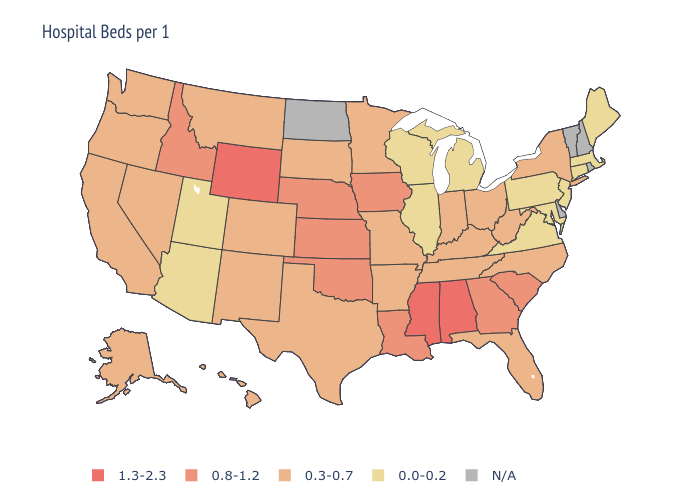Which states hav the highest value in the South?
Give a very brief answer. Alabama, Mississippi. Name the states that have a value in the range 0.8-1.2?
Short answer required. Georgia, Idaho, Iowa, Kansas, Louisiana, Nebraska, Oklahoma, South Carolina. What is the value of Arizona?
Write a very short answer. 0.0-0.2. What is the highest value in states that border North Carolina?
Keep it brief. 0.8-1.2. What is the highest value in the South ?
Keep it brief. 1.3-2.3. Name the states that have a value in the range 0.8-1.2?
Short answer required. Georgia, Idaho, Iowa, Kansas, Louisiana, Nebraska, Oklahoma, South Carolina. What is the value of South Dakota?
Give a very brief answer. 0.3-0.7. What is the value of Delaware?
Short answer required. N/A. Among the states that border Kentucky , which have the highest value?
Answer briefly. Indiana, Missouri, Ohio, Tennessee, West Virginia. Does New York have the lowest value in the Northeast?
Concise answer only. No. Does the first symbol in the legend represent the smallest category?
Keep it brief. No. Does the first symbol in the legend represent the smallest category?
Concise answer only. No. What is the lowest value in states that border Colorado?
Be succinct. 0.0-0.2. Among the states that border Wyoming , does Colorado have the lowest value?
Short answer required. No. What is the highest value in the South ?
Keep it brief. 1.3-2.3. 